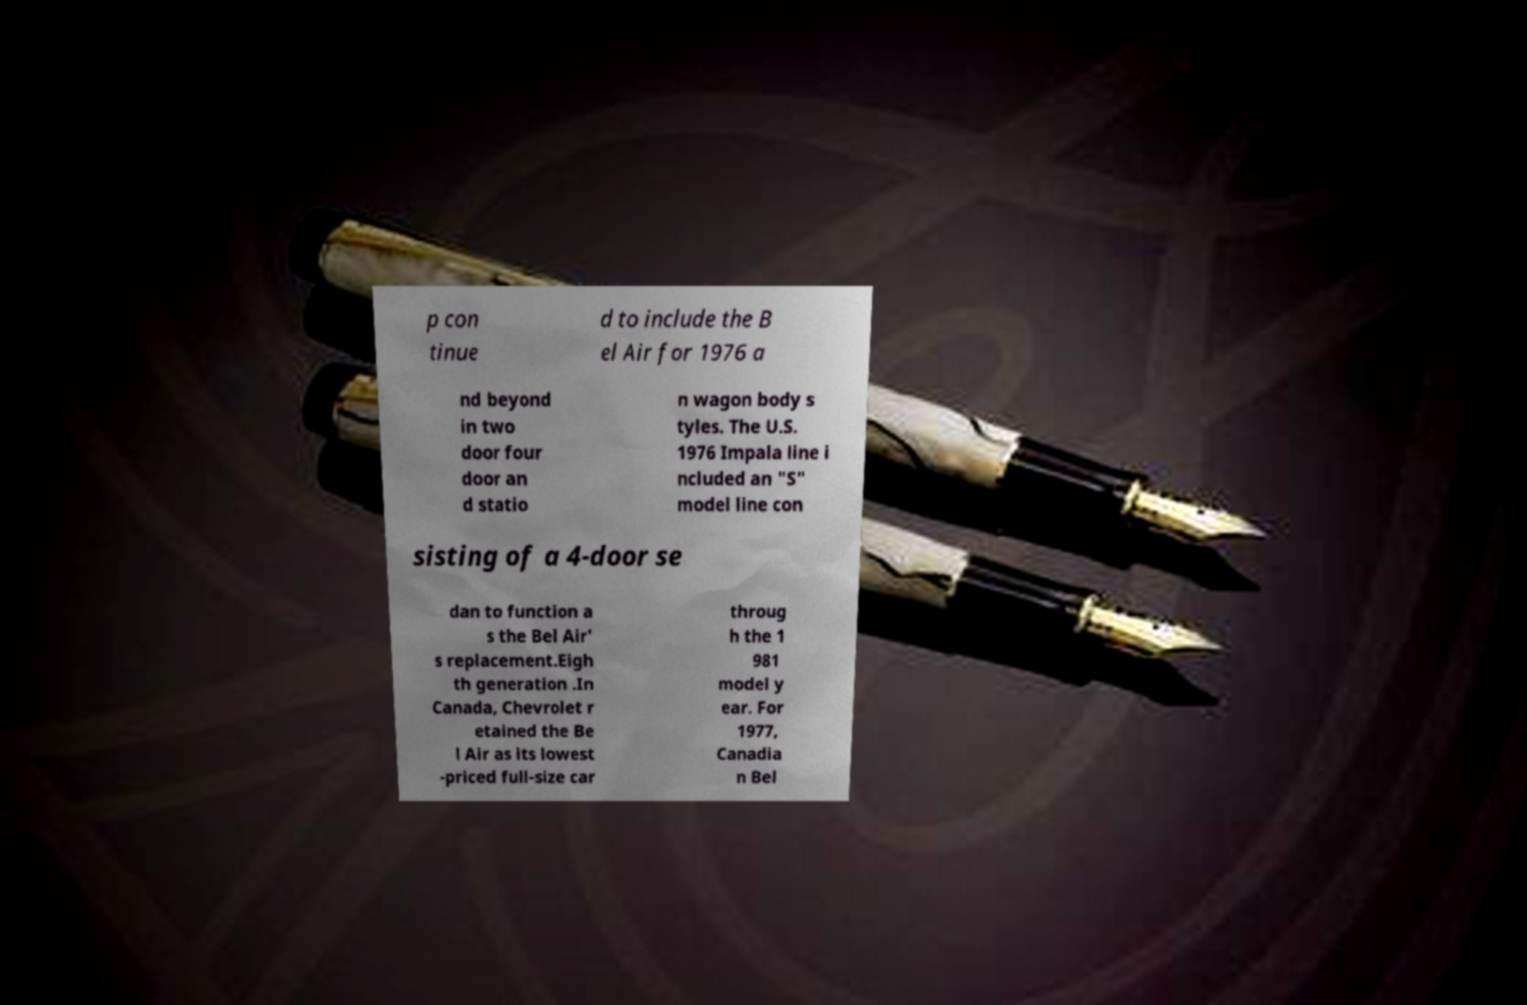Could you assist in decoding the text presented in this image and type it out clearly? p con tinue d to include the B el Air for 1976 a nd beyond in two door four door an d statio n wagon body s tyles. The U.S. 1976 Impala line i ncluded an "S" model line con sisting of a 4-door se dan to function a s the Bel Air' s replacement.Eigh th generation .In Canada, Chevrolet r etained the Be l Air as its lowest -priced full-size car throug h the 1 981 model y ear. For 1977, Canadia n Bel 